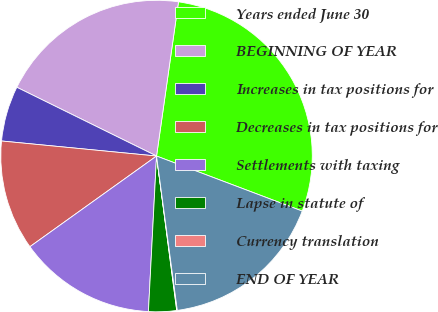Convert chart. <chart><loc_0><loc_0><loc_500><loc_500><pie_chart><fcel>Years ended June 30<fcel>BEGINNING OF YEAR<fcel>Increases in tax positions for<fcel>Decreases in tax positions for<fcel>Settlements with taxing<fcel>Lapse in statute of<fcel>Currency translation<fcel>END OF YEAR<nl><fcel>28.5%<fcel>19.97%<fcel>5.74%<fcel>11.43%<fcel>14.28%<fcel>2.9%<fcel>0.06%<fcel>17.12%<nl></chart> 